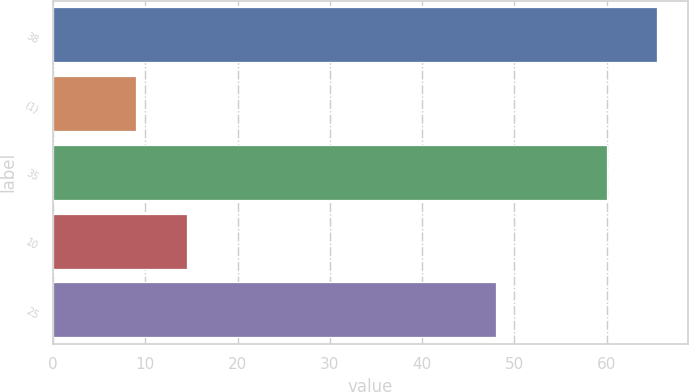Convert chart. <chart><loc_0><loc_0><loc_500><loc_500><bar_chart><fcel>38<fcel>(1)<fcel>35<fcel>10<fcel>25<nl><fcel>65.5<fcel>9<fcel>60<fcel>14.5<fcel>48<nl></chart> 